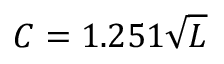<formula> <loc_0><loc_0><loc_500><loc_500>C = 1 . 2 5 1 { \sqrt { L } }</formula> 